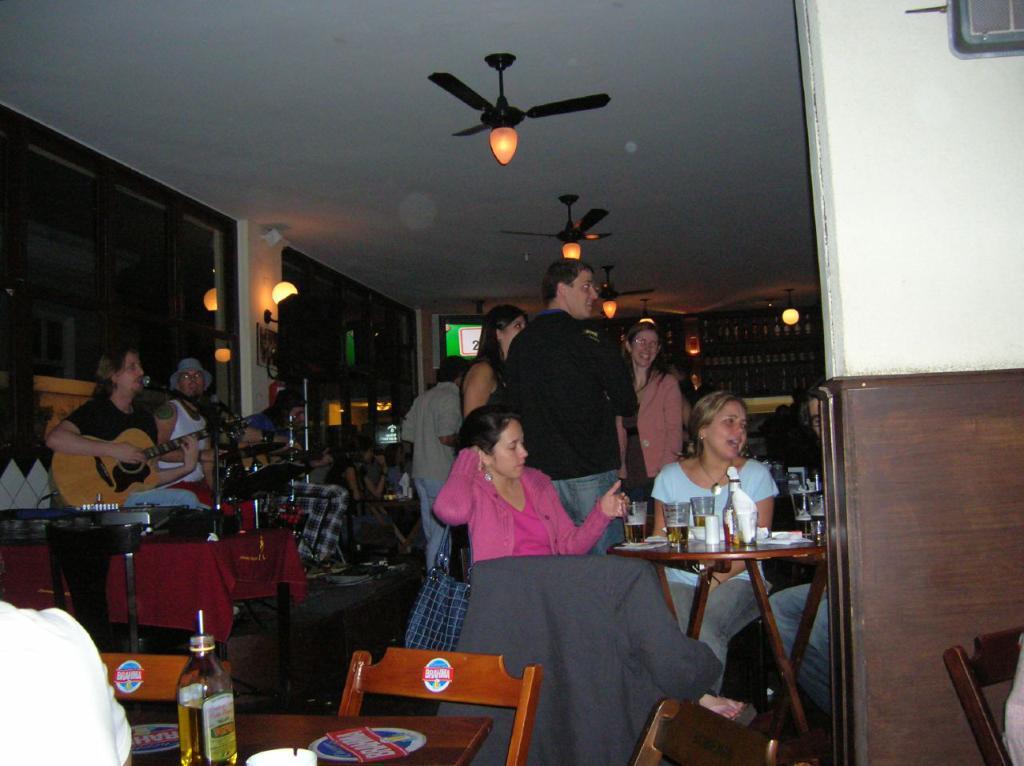Describe this image in one or two sentences. There is a group of people. There is a room. Some people are sitting and some people are standing. There is a table. There is a bottles,wine glass on a table. We can see the background there is a fan and lights. On the left side we have a person. His playing a guitar. 